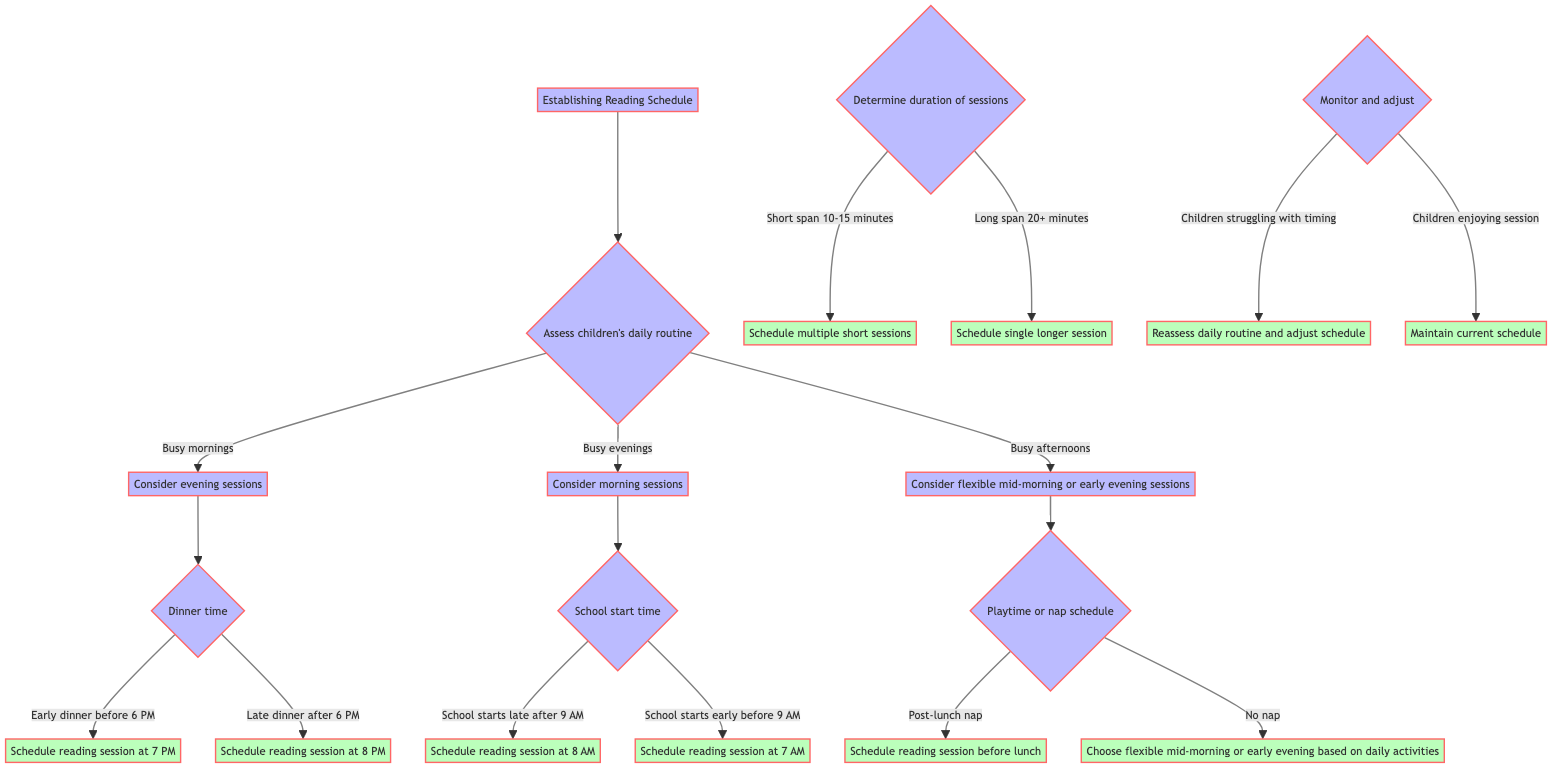What should be considered if children have busy mornings? If children have busy mornings, the decision tree suggests to consider evening sessions for reading. This is indicated directly under the "Assess children's daily routine" node.
Answer: Consider evening sessions What time should the reading session be scheduled for a late dinner? The flowchart shows that if there is a late dinner (after 6 PM), the reading session should be scheduled at 8 PM. This is outlined in the "Dinner time" decision.
Answer: Schedule reading session at 8 PM How many main criteria are there for establishing a reading schedule? The diagram lists three main criteria under the "Establishing Reading Schedule" node: "Assess children's daily routine," "Determine duration of sessions," and "Monitor and adjust." Therefore, there are three primary criteria.
Answer: Three What action should be taken if the children's attention span is short? According to the diagram, if children's attention spans are short (10-15 minutes), the action to take is to schedule multiple short sessions as indicated in the "Determine duration of sessions" section.
Answer: Schedule multiple short sessions What happens if children are struggling with the current reading schedule? The decision tree specifies that if children are struggling with timing, the action to take is to reassess the daily routine and adjust the schedule to better fit their needs.
Answer: Reassess daily routine and adjust schedule What type of reading session is recommended when the school starts late? When the school starts late (after 9 AM), the diagram recommends scheduling the reading session at 8 AM under the "School start time" sub-decision.
Answer: Schedule reading session at 8 AM What to choose if there is no nap in the children's schedule? If there is no nap in the children's schedule, the decision tree suggests choosing flexible mid-morning or early evening sessions based on daily activities, as shown in the "Playtime or nap schedule" section.
Answer: Choose flexible mid-morning or early evening based on daily activities What should be done if the children are enjoying the reading session currently? The flowchart indicates that if the children are enjoying the session, the appropriate action is to maintain the current schedule as detailed in the "Monitor and adjust" node.
Answer: Maintain current schedule 